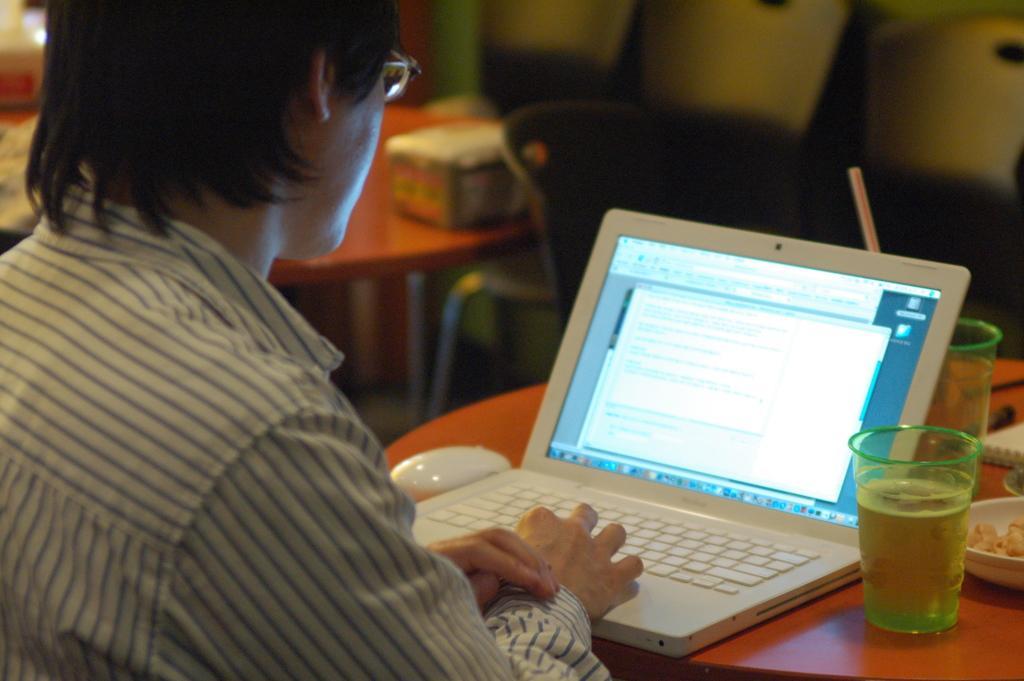Please provide a concise description of this image. This man is working on this laptop. In-front of this man there is a table, on this table there is a laptop, mouse, glass of water, book, pen and bowl. Far there is a chair and table, on this table there is a box. 